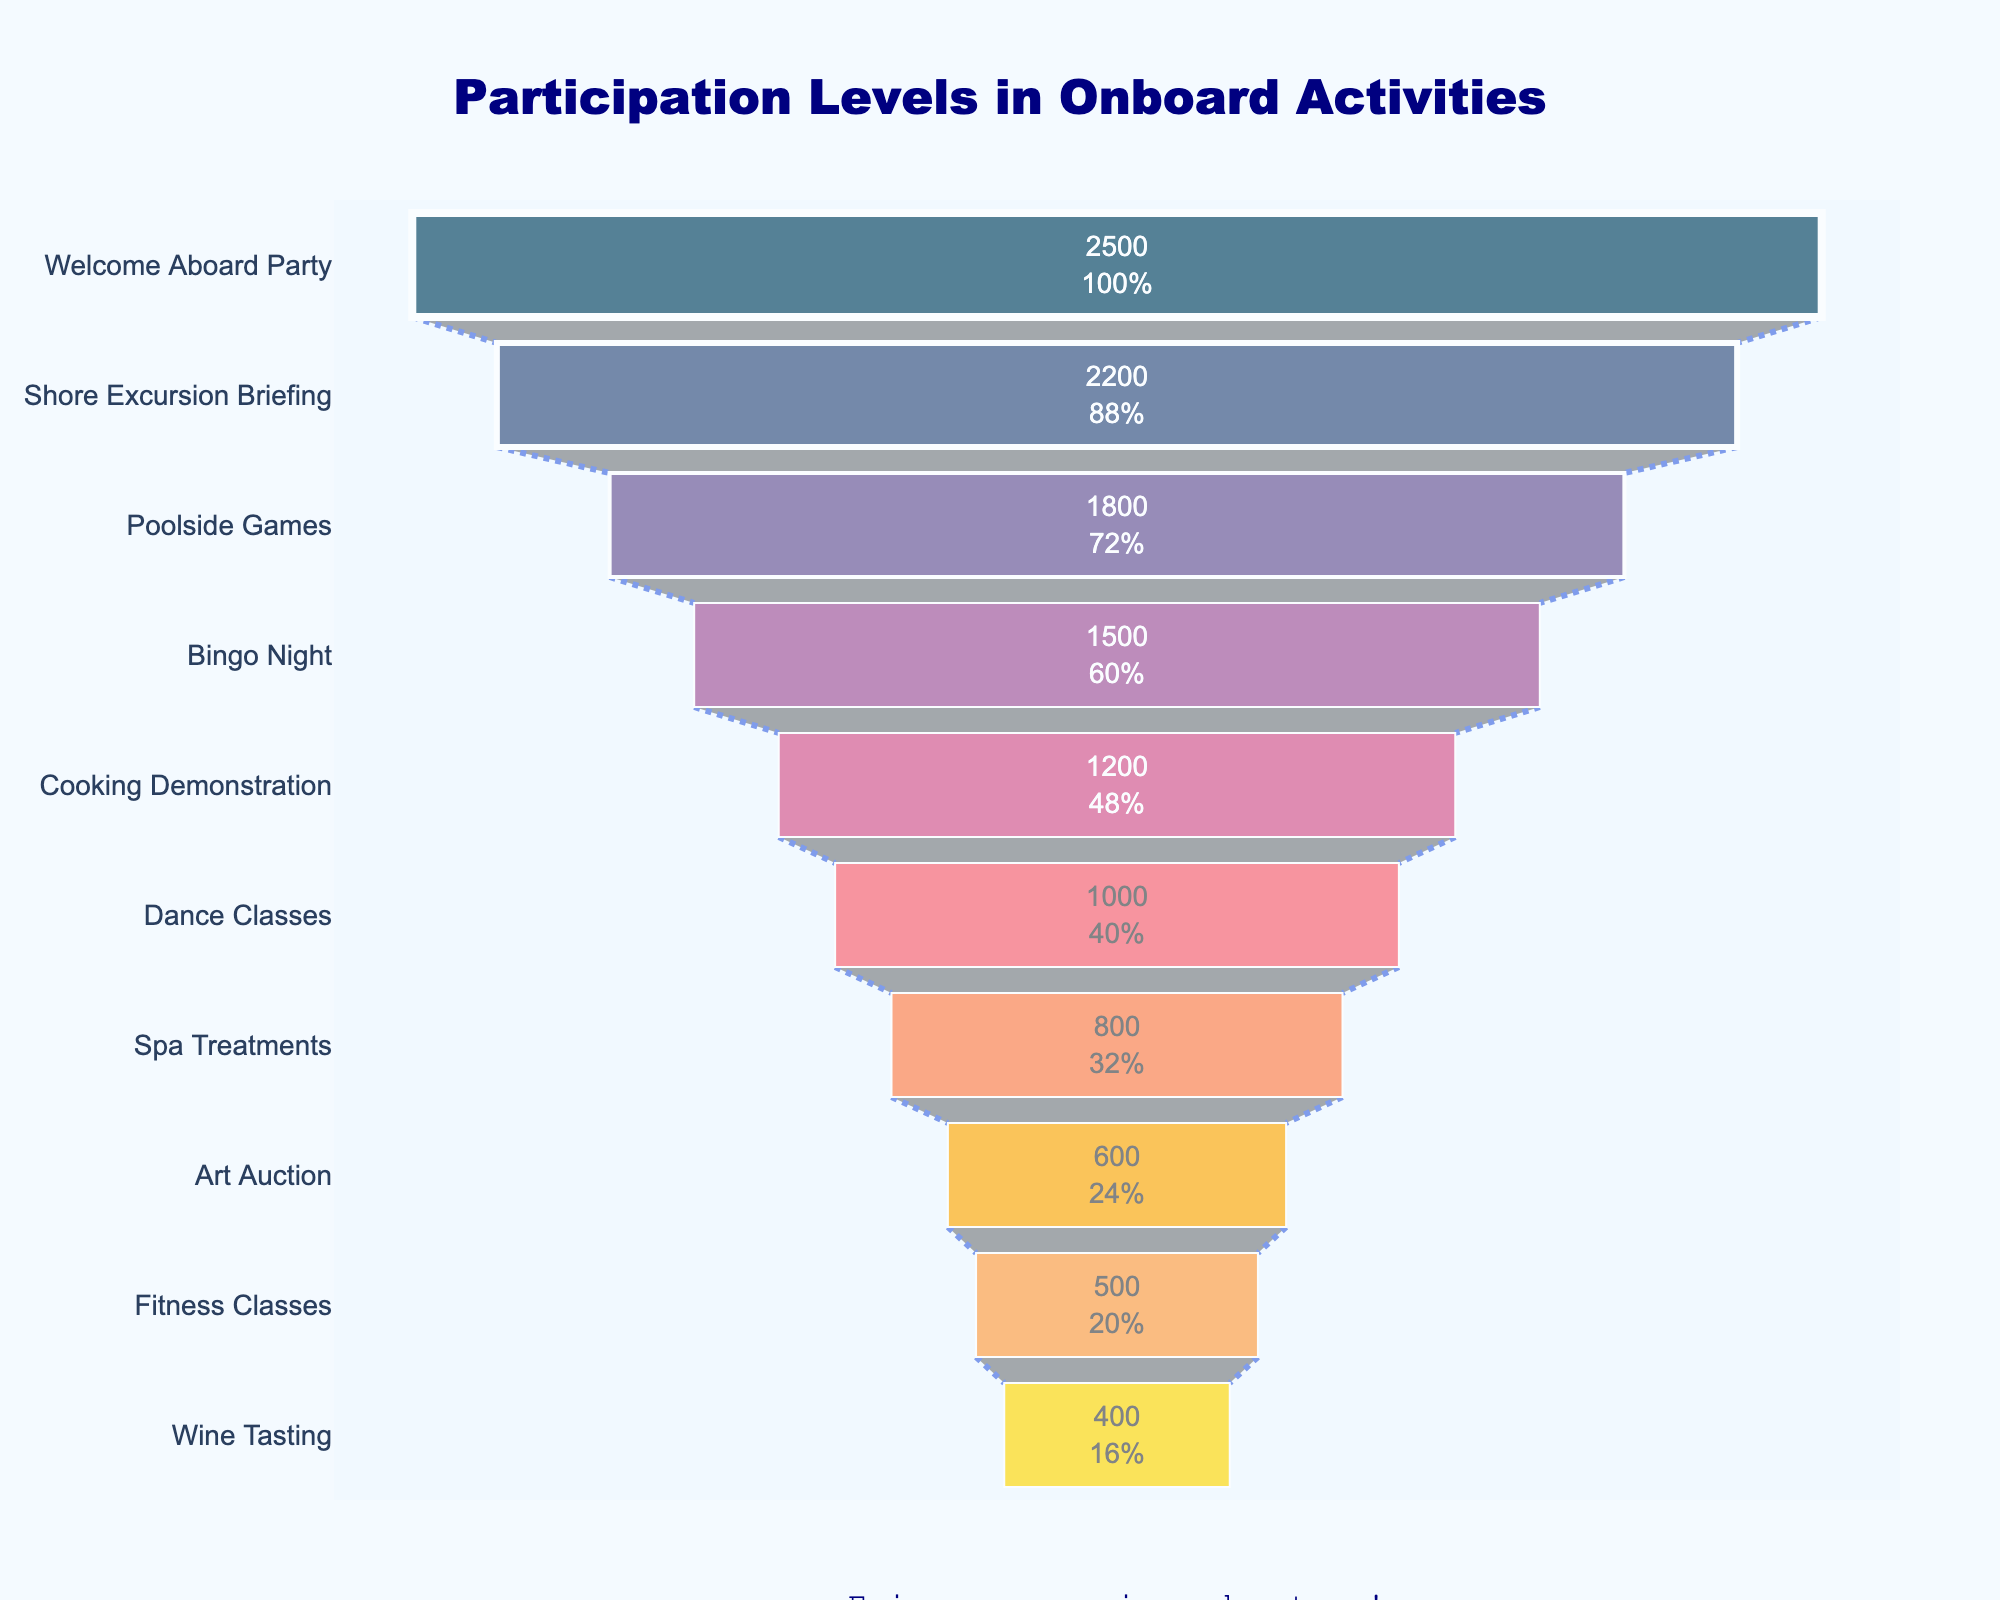Which activity had the highest number of participants? By looking at the funnel chart, the activity with the widest section at the top is the one with the highest number of participants. Here, "Welcome Aboard Party" is at the top with 2500 participants.
Answer: Welcome Aboard Party What is the title of the chart? The title of the chart is displayed at the top center of the figure. It reads "Participation Levels in Onboard Activities".
Answer: Participation Levels in Onboard Activities How many participants attended the Shore Excursion Briefing? The funnel chart lists the number of participants inside each section. Shore Excursion Briefing shows a value of 2200 participants.
Answer: 2200 Which activity had the fewest participants? The activity with the narrowest section at the bottom of the funnel chart has the fewest participants. "Wine Tasting" is at the bottom with 400 participants.
Answer: Wine Tasting What is the difference in the number of participants between Poolside Games and Bingo Night? Poolside Games had 1800 participants and Bingo Night had 1500 participants. Subtracting 1500 from 1800 gives a difference of 300 participants.
Answer: 300 What percentage of the participants attended the Dance Classes compared to the initial activity? The initial activity (Welcome Aboard Party) had 2500 participants, and Dance Classes had 1000. The percentage is calculated as (1000 / 2500) * 100 = 40%.
Answer: 40% What is the total number of participants for all onboard activities? Summing up the participants from each activity: 2500 + 2200 + 1800 + 1500 + 1200 + 1000 + 800 + 600 + 500 + 400 = 12500.
Answer: 12500 Which activity saw a drop of 500 participants from the previous activity? By comparing the numbers, Bingo Night had 1500 participants and the next activity, Cooking Demonstration, had 1200. The drop of participants is 300 (1500 - 1200 = 300), which is not what we need. The right activities are Shore Excursion Briefing with 2200 and Poolside Games with 1800 (2200 - 1800 = 400). Thus, there seems to be no activity with a drop of exactly 500 participants.
Answer: None How many more participants attended the Art Auction than the Fitness Classes? Art Auction had 600 participants, and Fitness Classes had 500 participants. The difference is 600 - 500 = 100 participants.
Answer: 100 What proportion of activities had fewer than 1000 participants? There are 10 activities listed in total. Those with fewer than 1000 participants are Spa Treatments, Art Auction, Fitness Classes, and Wine Tasting, which totals 4 activities out of 10. The proportion is 4/10 = 0.4, which is 40%.
Answer: 40% 